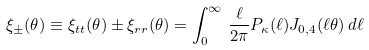Convert formula to latex. <formula><loc_0><loc_0><loc_500><loc_500>\xi _ { \pm } ( \theta ) \equiv \xi _ { t t } ( \theta ) \pm \xi _ { r r } ( \theta ) = \int _ { 0 } ^ { \infty } \, \frac { \ell } { 2 \pi } P _ { \kappa } ( \ell ) J _ { 0 , 4 } ( \ell \theta ) \, d \ell</formula> 